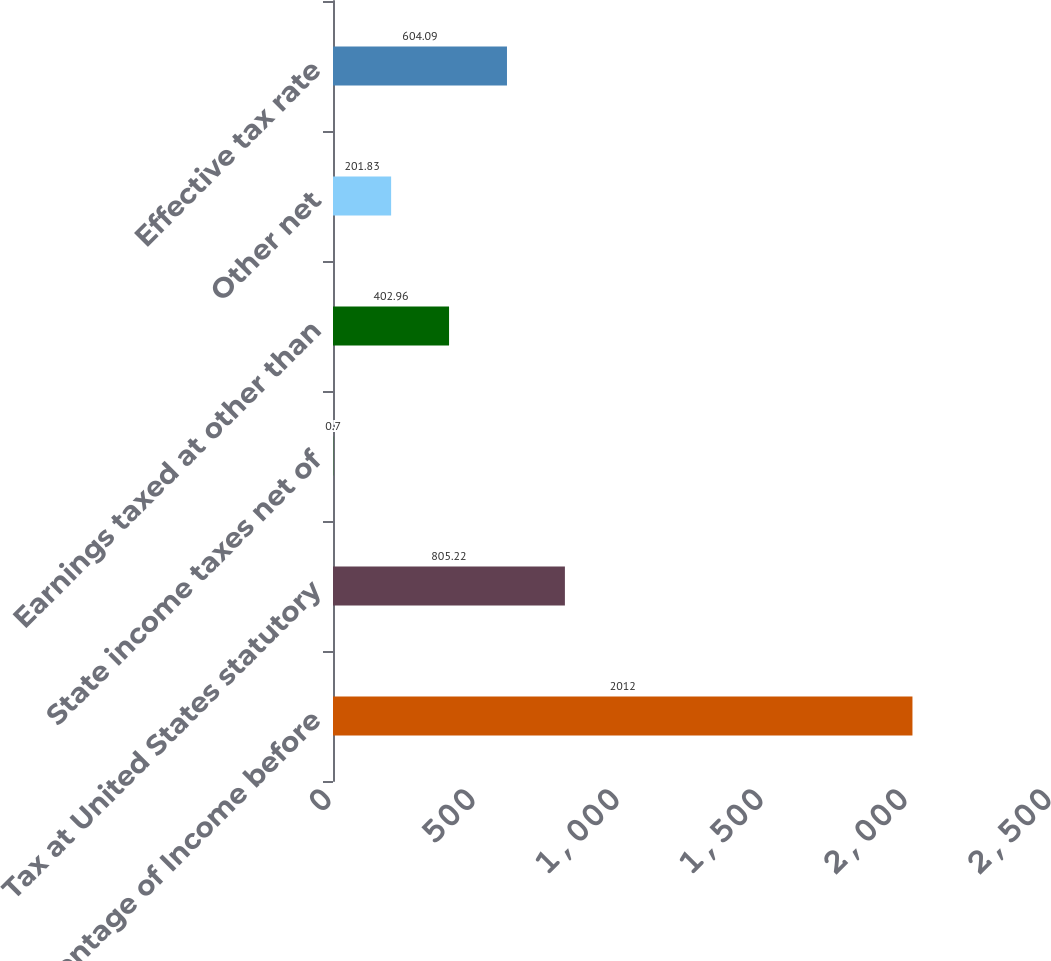Convert chart. <chart><loc_0><loc_0><loc_500><loc_500><bar_chart><fcel>Percentage of Income before<fcel>Tax at United States statutory<fcel>State income taxes net of<fcel>Earnings taxed at other than<fcel>Other net<fcel>Effective tax rate<nl><fcel>2012<fcel>805.22<fcel>0.7<fcel>402.96<fcel>201.83<fcel>604.09<nl></chart> 